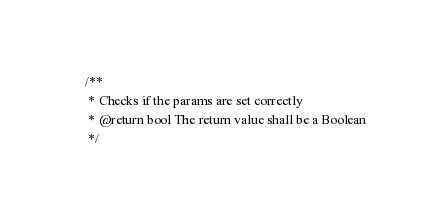<code> <loc_0><loc_0><loc_500><loc_500><_PHP_>
    /**
     * Checks if the params are set correctly
     * @return bool The return value shall be a Boolean
     */</code> 